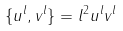<formula> <loc_0><loc_0><loc_500><loc_500>\{ u ^ { l } , v ^ { l } \} = l ^ { 2 } u ^ { l } v ^ { l }</formula> 